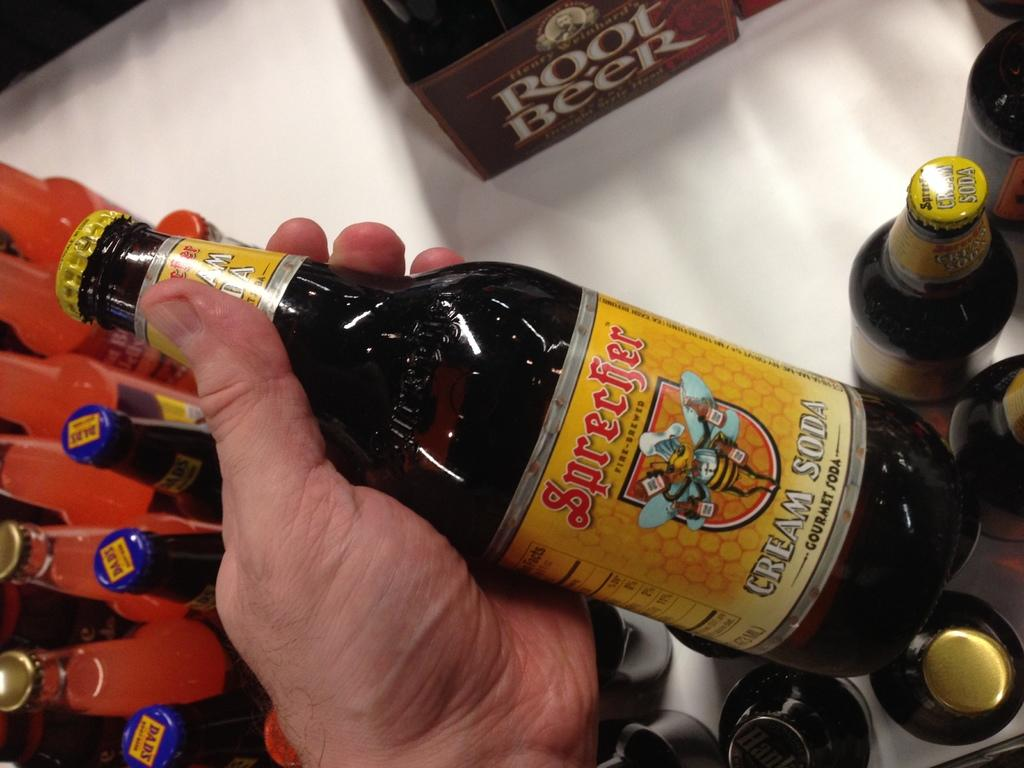<image>
Provide a brief description of the given image. A person holds a bottle of cream soda in their left hand. 